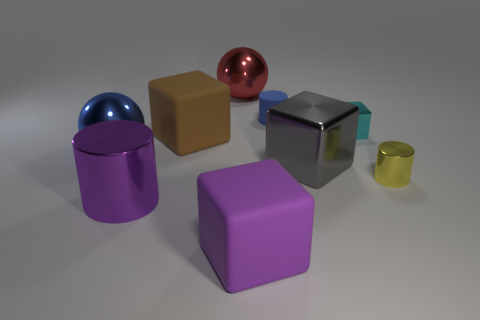Subtract 1 blocks. How many blocks are left? 3 Add 1 red rubber objects. How many objects exist? 10 Subtract all cylinders. How many objects are left? 6 Add 5 yellow objects. How many yellow objects exist? 6 Subtract 1 blue cylinders. How many objects are left? 8 Subtract all big brown rubber cylinders. Subtract all large things. How many objects are left? 3 Add 8 big purple objects. How many big purple objects are left? 10 